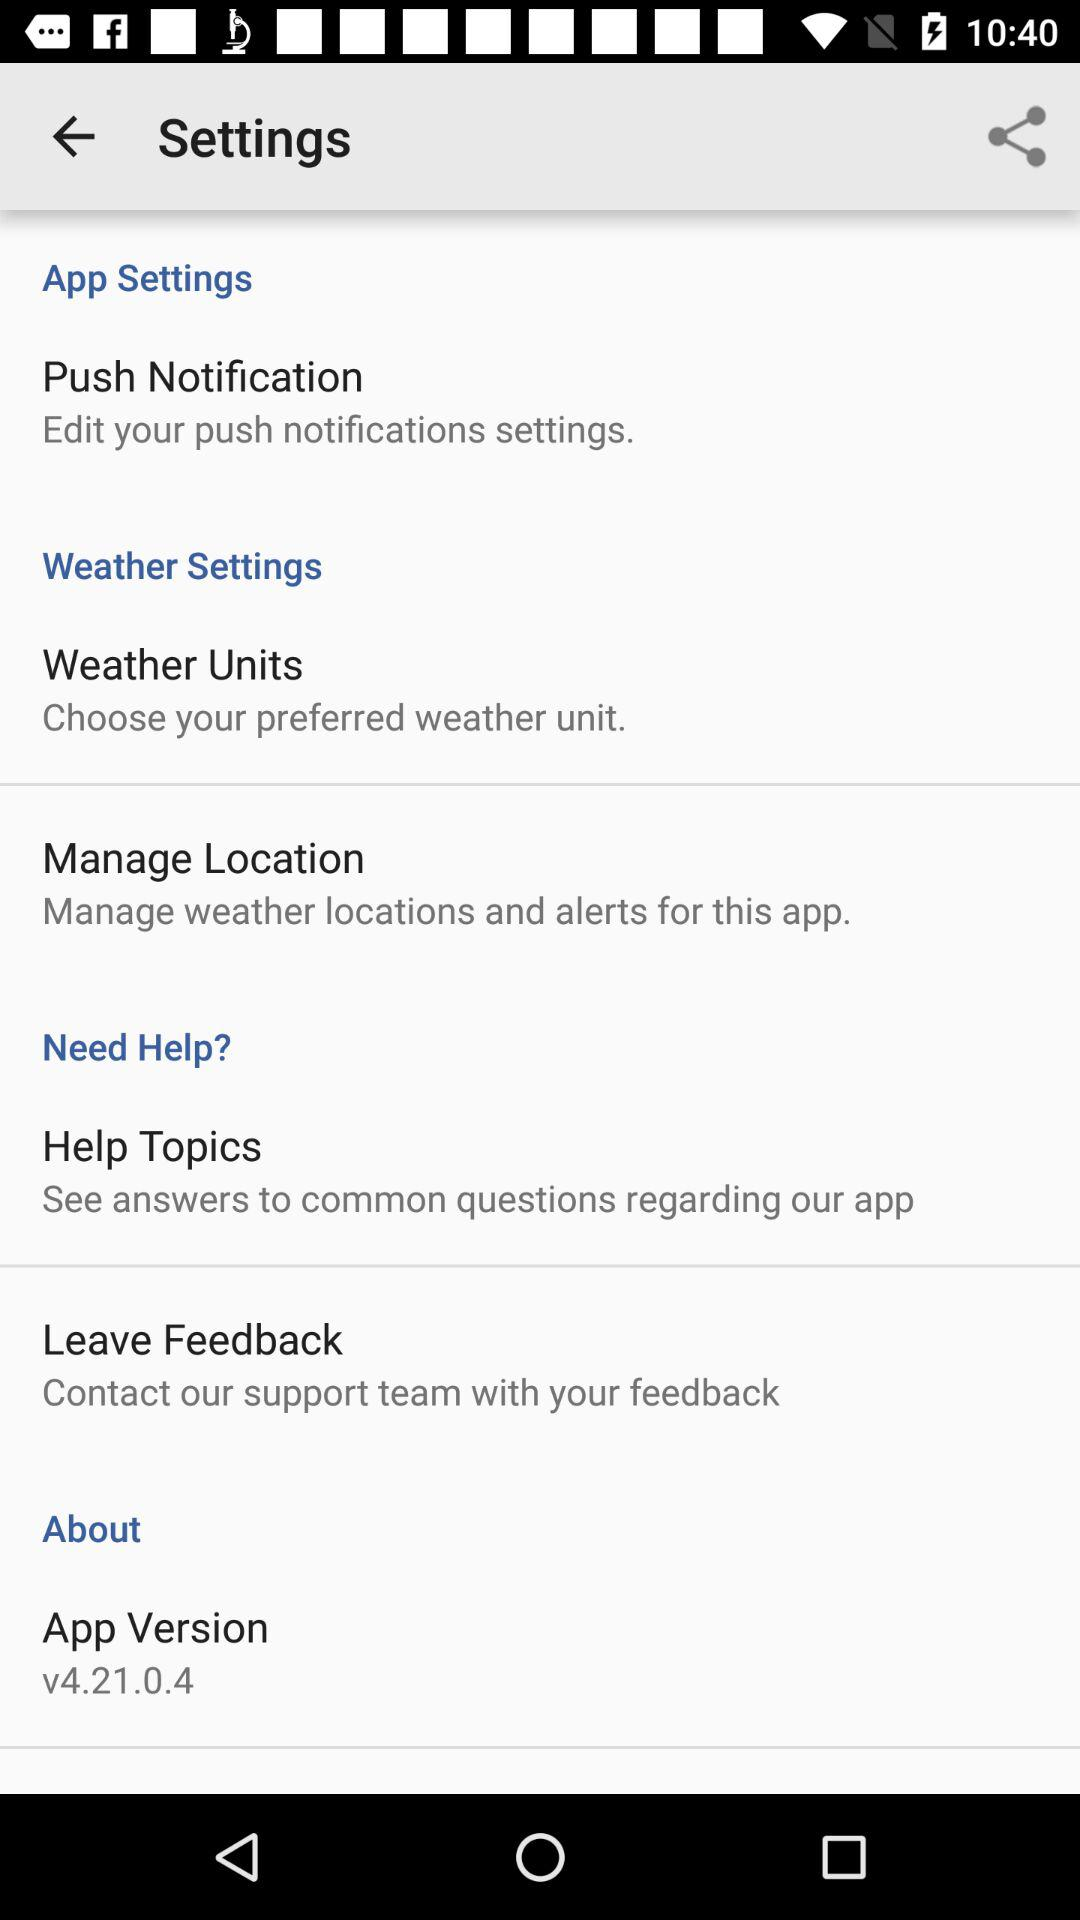How can users leave feedback? Users can leave feedback by contacting the support team. 